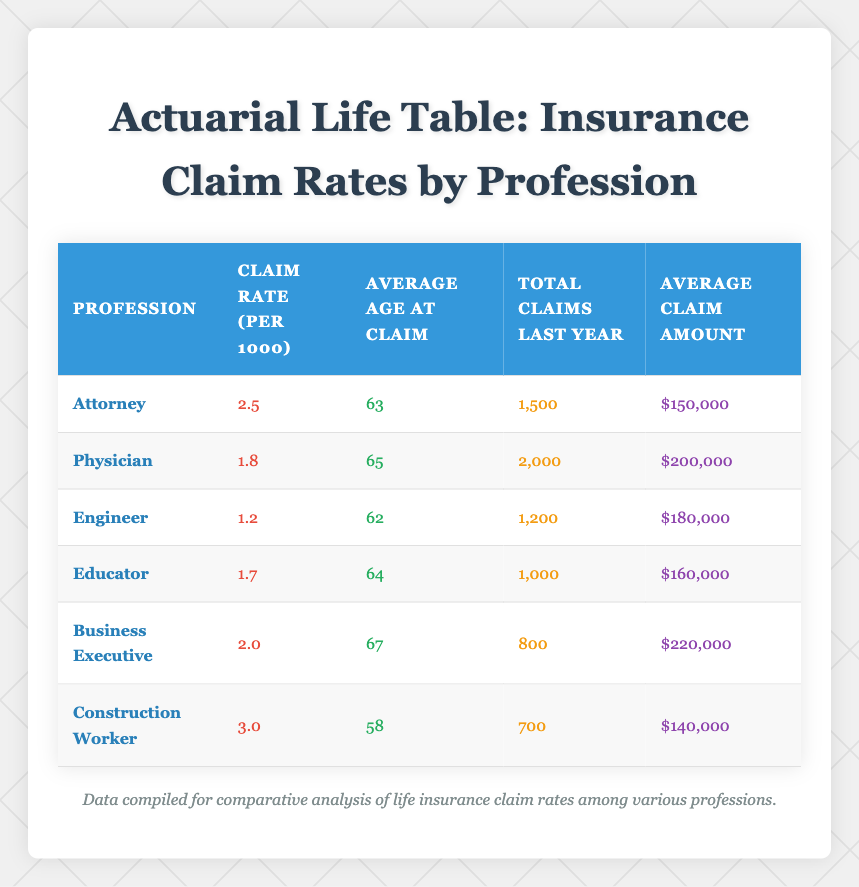What is the claim rate per 1000 for attorneys? Referring to the table, the claim rate for attorneys is listed directly under the "Claim Rate (per 1000)" column. For the attorney profession, the value provided is 2.5.
Answer: 2.5 What is the average age at claim for construction workers? The table displays the average age at claim for each profession. For construction workers, the corresponding age is found under the "Average Age at Claim" column, which shows 58.
Answer: 58 How many total claims were made by physicians last year? Looking at the "Total Claims Last Year" column in the table, we see that the total claims made by physicians was 2000.
Answer: 2000 Which profession has the highest average claim amount? To find the profession with the highest average claim amount, we check the values in the "Average Claim Amount" column. The highest value listed is $220,000 for Business Executives.
Answer: Business Executive What is the average claim rate for engineers and educators combined? The claim rates for engineers and educators are 1.2 and 1.7, respectively. To find the average, we add these together: 1.2 + 1.7 = 2.9, and then divide by 2, yielding 2.9/2 = 1.45.
Answer: 1.45 Is the average age at claim for attorneys younger than for business executives? The average age at claim for attorneys is 63, while for business executives, it is 67. Since 63 is less than 67, the statement is true.
Answer: Yes How does the total number of claims for construction workers compare to those for attorneys? From the table, construction workers had 700 total claims while attorneys had 1500. To compare, we see that 1500 is greater than 700. Thus, attorneys had more claims.
Answer: Attorneys had more claims What is the difference in average claim amounts between physicians and attorneys? The average claim amount for physicians is $200,000, and for attorneys, it is $150,000. To find the difference, we subtract: $200,000 - $150,000 = $50,000.
Answer: $50,000 Does any profession have a claim rate that is greater than 3.0? Reviewing the claim rates in the table, the maximum claim rate is 3.0 for construction workers, meaning no profession exceeds this rate. Therefore, the answer is no.
Answer: No 